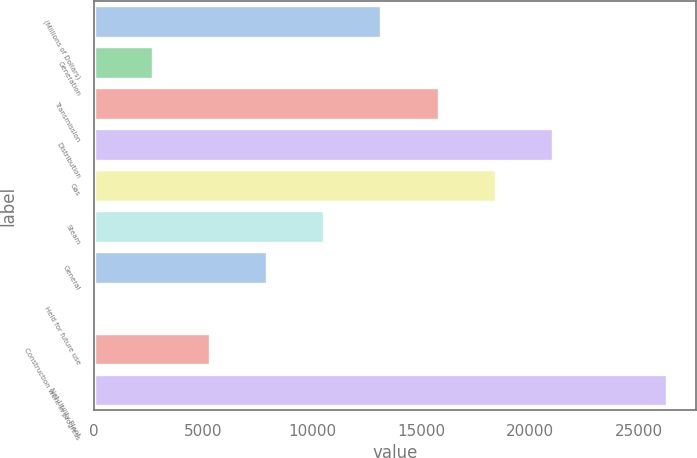Convert chart to OTSL. <chart><loc_0><loc_0><loc_500><loc_500><bar_chart><fcel>(Millions of Dollars)<fcel>Generation<fcel>Transmission<fcel>Distribution<fcel>Gas<fcel>Steam<fcel>General<fcel>Held for future use<fcel>Construction work in progress<fcel>Net Utility Plant<nl><fcel>13187<fcel>2695.8<fcel>15809.8<fcel>21055.4<fcel>18432.6<fcel>10564.2<fcel>7941.4<fcel>73<fcel>5318.6<fcel>26301<nl></chart> 